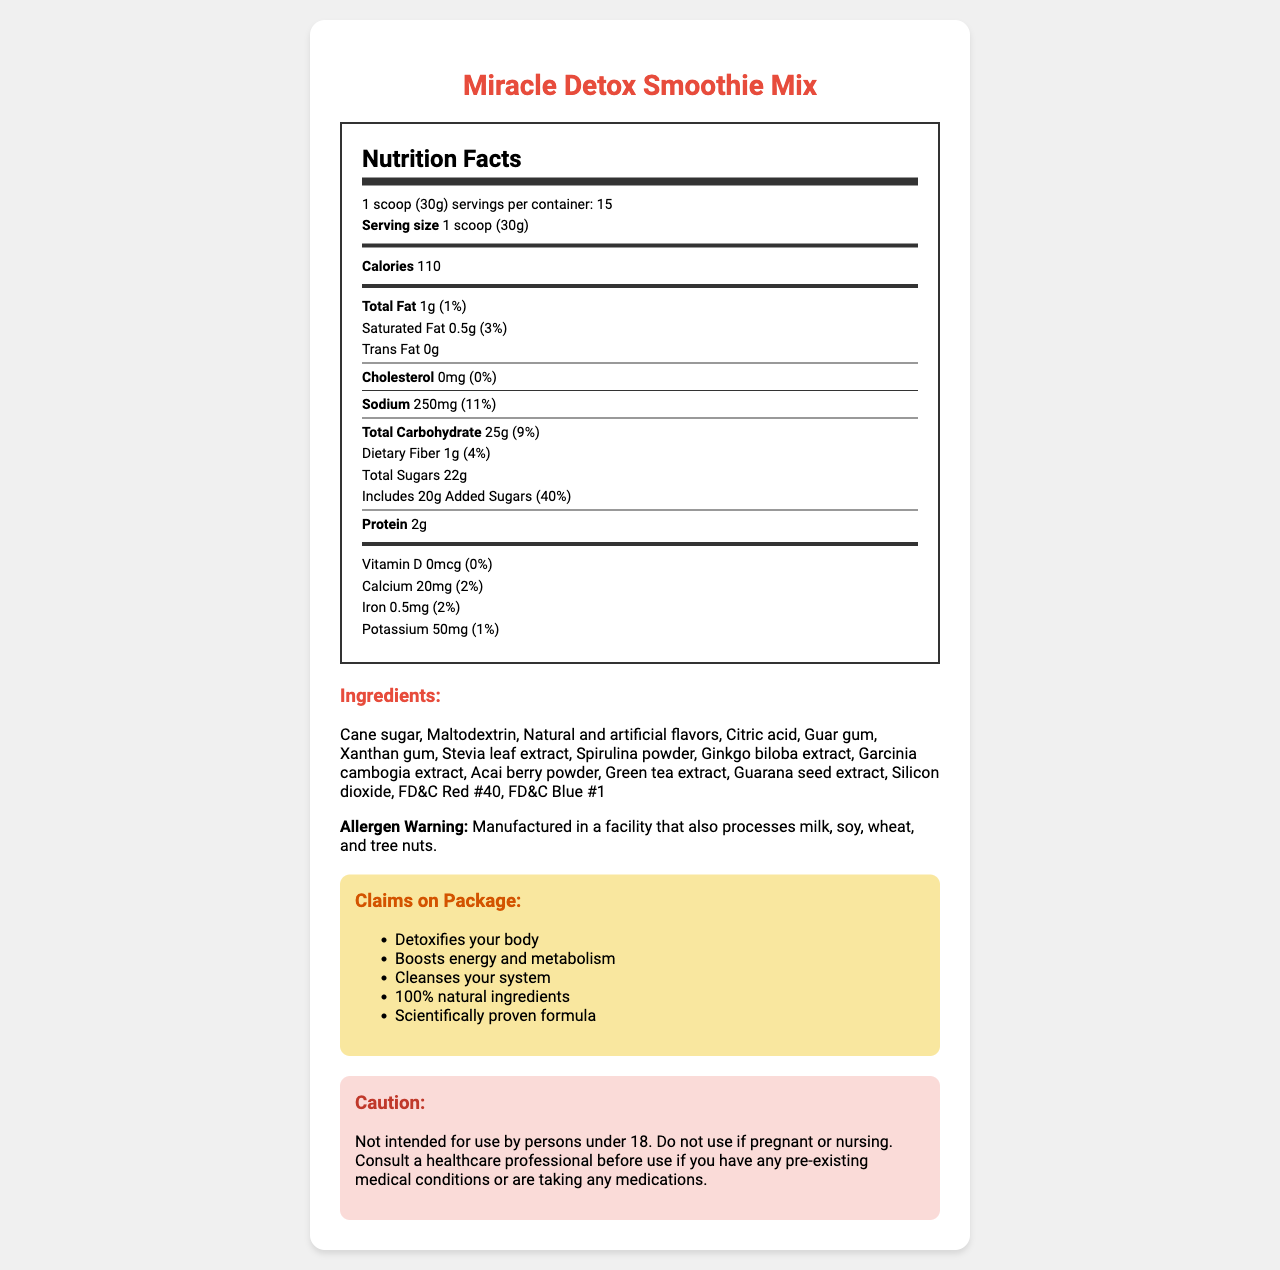what is the serving size? The document states the serving size as "1 scoop (30g)".
Answer: 1 scoop (30g) how many calories are in one serving of the Miracle Detox Smoothie Mix? The document mentions that one serving contains 110 calories.
Answer: 110 calories what is the total carbohydrate content per serving? According to the document, each serving contains 25g of total carbohydrates.
Answer: 25g what are the added sugars per serving, and what percentage of the daily value do they represent? The document lists added sugars as 20g per serving, which is 40% of the daily value.
Answer: 20g, 40% what ingredients are listed as natural or artificial flavors? The document includes "Natural and artificial flavors" in the list of ingredients.
Answer: Natural and artificial flavors how much sodium does one serving contain? A. 150mg B. 250mg C. 350mg D. 450mg The document states that one serving contains 250mg of sodium.
Answer: B. 250mg which ingredient is NOT included in the Miracle Detox Smoothie Mix? I. Guar gum II. Spirulina powder III. Corn syrup IV. Stevia leaf extract The document does not list corn syrup as an ingredient.
Answer: III. Corn syrup is the Miracle Detox Smoothie Mix suitable for someone with milk allergies? The document warns that it is manufactured in a facility that processes milk, soy, wheat, and tree nuts.
Answer: No what is the main purpose described for the Miracle Detox Smoothie Mix according to the claims on the package? One of the primary claims on the package is that it detoxifies your body.
Answer: Detoxifies your body what caution is given for individuals under 18 years old? The cautionary statement specifies that the product is not intended for individuals under 18.
Answer: Not intended for use by persons under 18. describe the main idea of the document The document includes detailed nutritional information, the ingredient list, various health claims the product makes, as well as warnings regarding the consumption of the product.
Answer: The document provides the nutrition facts and ingredient details of the "Miracle Detox Smoothie Mix". It highlights the serving size, calorie content, nutrients, ingredients, allergen warnings, promotional claims, and cautionary statements for users. how many grams of trans fat are in one serving? The document specifies that there are 0g of trans fat in one serving.
Answer: 0g what is the percentage daily value of saturated fat per serving? The document indicates that the percentage daily value of saturated fat per serving is 3%.
Answer: 3% how much protein is in one serving? The document states that one serving contains 2g of protein.
Answer: 2g are there any artificial colors listed in the ingredients? The ingredients include "FD&C Red #40" and "FD&C Blue #1", which are artificial colors.
Answer: Yes does the Miracle Detox Smoothie Mix contain any dietary fiber? The document indicates that one serving contains 1g of dietary fiber.
Answer: Yes what is the age restriction for the use of the Miracle Detox Smoothie Mix? The cautionary statement mentions that the product is not intended for use by persons under 18.
Answer: Under 18 years should not use it. can we determine if the product is scientifically proven as claimed on the package? The claim that the formula is "scientifically proven" is mentioned, but there are no details in the document to support or verify this claim.
Answer: Not enough information 